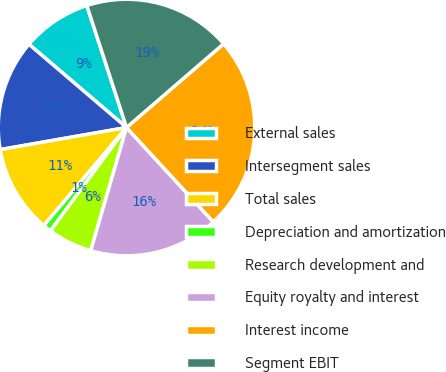<chart> <loc_0><loc_0><loc_500><loc_500><pie_chart><fcel>External sales<fcel>Intersegment sales<fcel>Total sales<fcel>Depreciation and amortization<fcel>Research development and<fcel>Equity royalty and interest<fcel>Interest income<fcel>Segment EBIT<nl><fcel>8.75%<fcel>14.0%<fcel>11.09%<fcel>1.05%<fcel>5.6%<fcel>16.34%<fcel>24.49%<fcel>18.68%<nl></chart> 